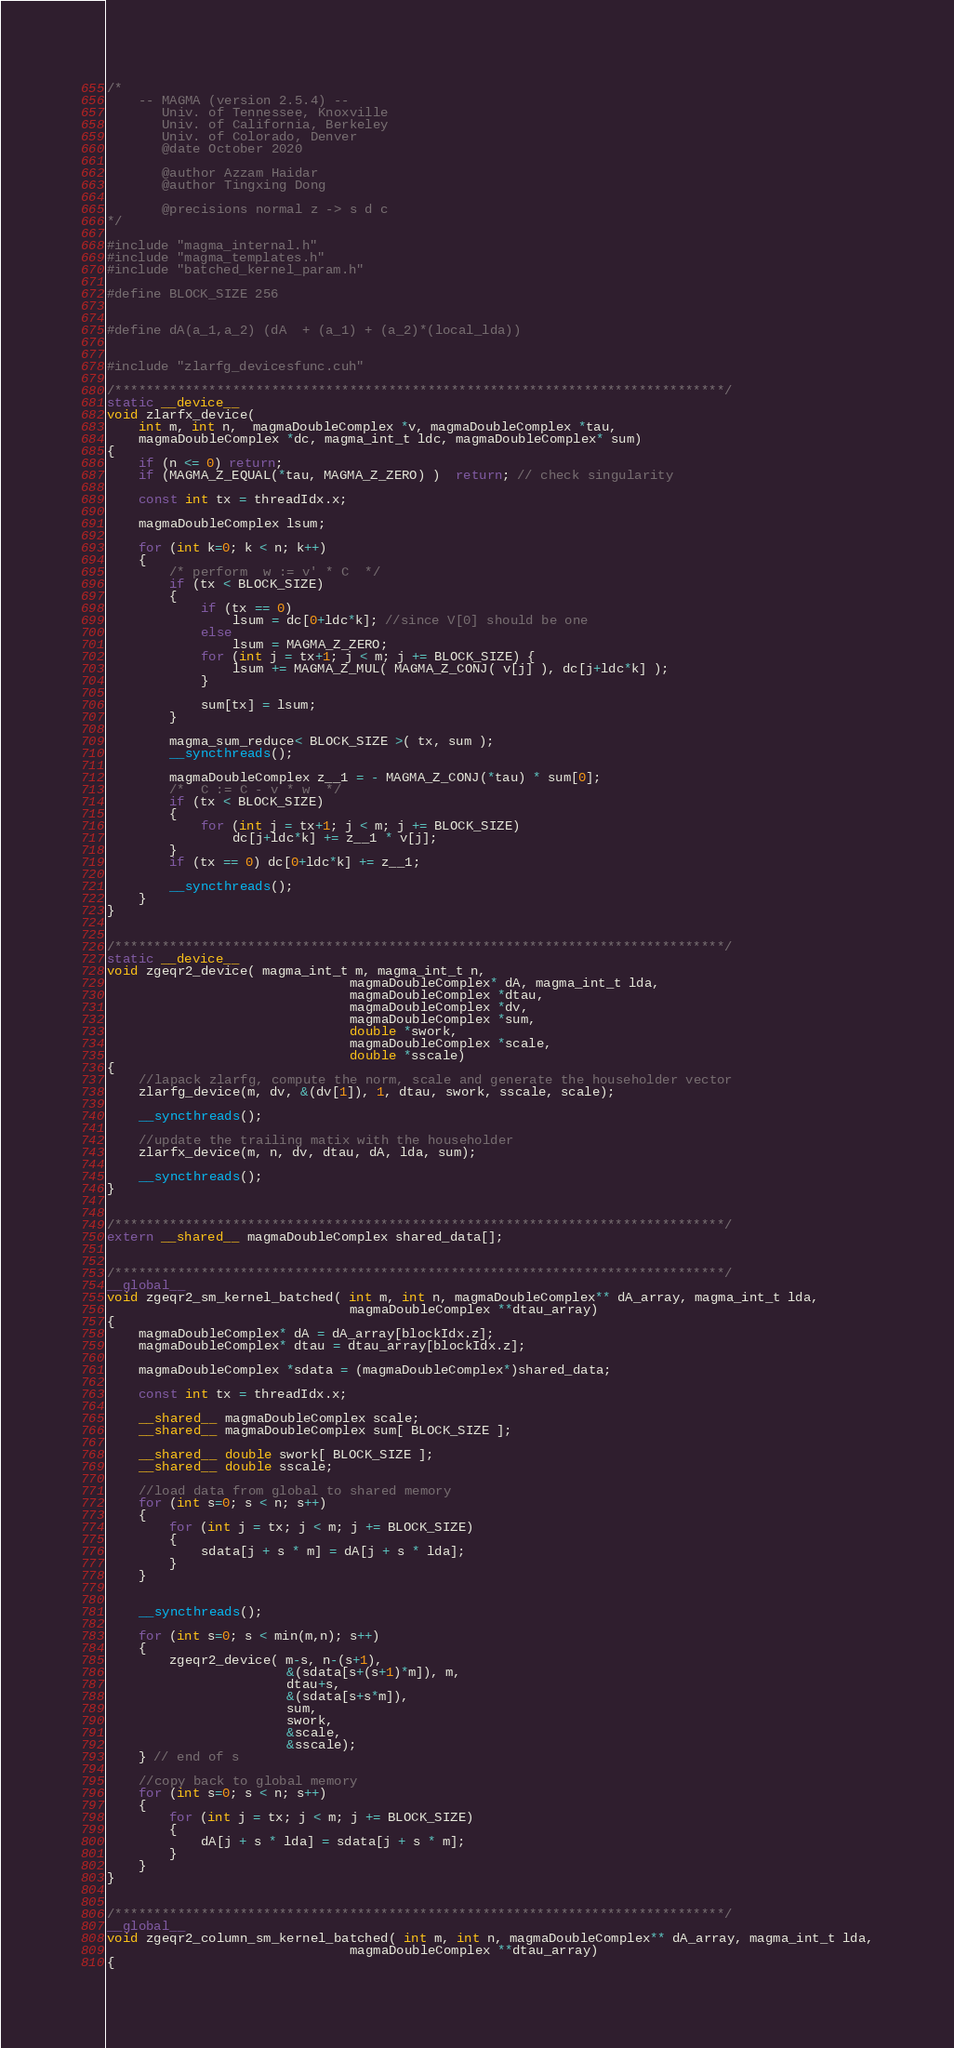<code> <loc_0><loc_0><loc_500><loc_500><_Cuda_>/*
    -- MAGMA (version 2.5.4) --
       Univ. of Tennessee, Knoxville
       Univ. of California, Berkeley
       Univ. of Colorado, Denver
       @date October 2020

       @author Azzam Haidar
       @author Tingxing Dong

       @precisions normal z -> s d c
*/

#include "magma_internal.h"
#include "magma_templates.h"
#include "batched_kernel_param.h"

#define BLOCK_SIZE 256


#define dA(a_1,a_2) (dA  + (a_1) + (a_2)*(local_lda))


#include "zlarfg_devicesfunc.cuh"

/******************************************************************************/
static __device__
void zlarfx_device(
    int m, int n,  magmaDoubleComplex *v, magmaDoubleComplex *tau,
    magmaDoubleComplex *dc, magma_int_t ldc, magmaDoubleComplex* sum)
{
    if (n <= 0) return;
    if (MAGMA_Z_EQUAL(*tau, MAGMA_Z_ZERO) )  return; // check singularity

    const int tx = threadIdx.x;

    magmaDoubleComplex lsum;

    for (int k=0; k < n; k++)
    {
        /* perform  w := v' * C  */
        if (tx < BLOCK_SIZE)
        {
            if (tx == 0)
                lsum = dc[0+ldc*k]; //since V[0] should be one
            else
                lsum = MAGMA_Z_ZERO;
            for (int j = tx+1; j < m; j += BLOCK_SIZE) {
                lsum += MAGMA_Z_MUL( MAGMA_Z_CONJ( v[j] ), dc[j+ldc*k] );
            }

            sum[tx] = lsum;
        }

        magma_sum_reduce< BLOCK_SIZE >( tx, sum );
        __syncthreads();

        magmaDoubleComplex z__1 = - MAGMA_Z_CONJ(*tau) * sum[0];
        /*  C := C - v * w  */
        if (tx < BLOCK_SIZE)
        {
            for (int j = tx+1; j < m; j += BLOCK_SIZE)
                dc[j+ldc*k] += z__1 * v[j];
        }
        if (tx == 0) dc[0+ldc*k] += z__1;

        __syncthreads();
    }
}


/******************************************************************************/
static __device__
void zgeqr2_device( magma_int_t m, magma_int_t n,
                               magmaDoubleComplex* dA, magma_int_t lda,
                               magmaDoubleComplex *dtau,
                               magmaDoubleComplex *dv,
                               magmaDoubleComplex *sum,
                               double *swork,
                               magmaDoubleComplex *scale,
                               double *sscale)
{
    //lapack zlarfg, compute the norm, scale and generate the householder vector
    zlarfg_device(m, dv, &(dv[1]), 1, dtau, swork, sscale, scale);

    __syncthreads();

    //update the trailing matix with the householder
    zlarfx_device(m, n, dv, dtau, dA, lda, sum);

    __syncthreads();
}


/******************************************************************************/
extern __shared__ magmaDoubleComplex shared_data[];


/******************************************************************************/
__global__
void zgeqr2_sm_kernel_batched( int m, int n, magmaDoubleComplex** dA_array, magma_int_t lda,
                               magmaDoubleComplex **dtau_array)
{
    magmaDoubleComplex* dA = dA_array[blockIdx.z];
    magmaDoubleComplex* dtau = dtau_array[blockIdx.z];

    magmaDoubleComplex *sdata = (magmaDoubleComplex*)shared_data;

    const int tx = threadIdx.x;

    __shared__ magmaDoubleComplex scale;
    __shared__ magmaDoubleComplex sum[ BLOCK_SIZE ];

    __shared__ double swork[ BLOCK_SIZE ];
    __shared__ double sscale;

    //load data from global to shared memory
    for (int s=0; s < n; s++)
    {
        for (int j = tx; j < m; j += BLOCK_SIZE)
        {
            sdata[j + s * m] = dA[j + s * lda];
        }
    }


    __syncthreads();

    for (int s=0; s < min(m,n); s++)
    {
        zgeqr2_device( m-s, n-(s+1),
                       &(sdata[s+(s+1)*m]), m,
                       dtau+s,
                       &(sdata[s+s*m]),
                       sum,
                       swork,
                       &scale,
                       &sscale);
    } // end of s

    //copy back to global memory
    for (int s=0; s < n; s++)
    {
        for (int j = tx; j < m; j += BLOCK_SIZE)
        {
            dA[j + s * lda] = sdata[j + s * m];
        }
    }
}


/******************************************************************************/
__global__
void zgeqr2_column_sm_kernel_batched( int m, int n, magmaDoubleComplex** dA_array, magma_int_t lda,
                               magmaDoubleComplex **dtau_array)
{</code> 